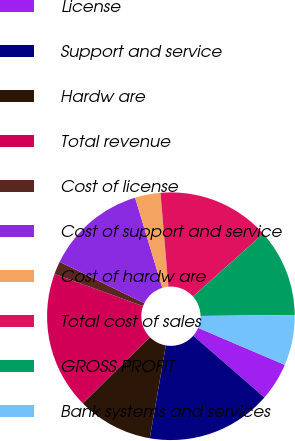<chart> <loc_0><loc_0><loc_500><loc_500><pie_chart><fcel>License<fcel>Support and service<fcel>Hardw are<fcel>Total revenue<fcel>Cost of license<fcel>Cost of support and service<fcel>Cost of hardw are<fcel>Total cost of sales<fcel>GROSS PROFIT<fcel>Bank systems and services<nl><fcel>4.96%<fcel>16.35%<fcel>9.84%<fcel>17.97%<fcel>1.7%<fcel>13.09%<fcel>3.33%<fcel>14.72%<fcel>11.46%<fcel>6.58%<nl></chart> 